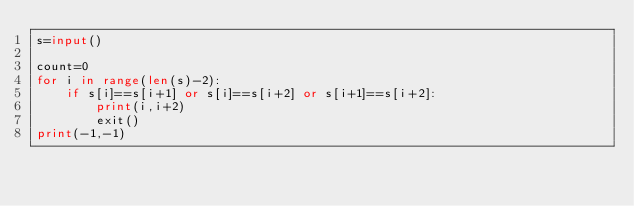Convert code to text. <code><loc_0><loc_0><loc_500><loc_500><_Python_>s=input()

count=0
for i in range(len(s)-2):
    if s[i]==s[i+1] or s[i]==s[i+2] or s[i+1]==s[i+2]:
        print(i,i+2)
        exit()
print(-1,-1)</code> 